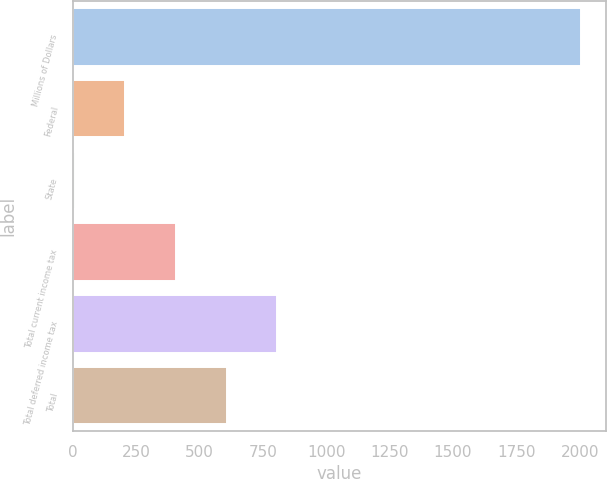Convert chart to OTSL. <chart><loc_0><loc_0><loc_500><loc_500><bar_chart><fcel>Millions of Dollars<fcel>Federal<fcel>State<fcel>Total current income tax<fcel>Total deferred income tax<fcel>Total<nl><fcel>2004<fcel>207.6<fcel>8<fcel>407.2<fcel>806.4<fcel>606.8<nl></chart> 